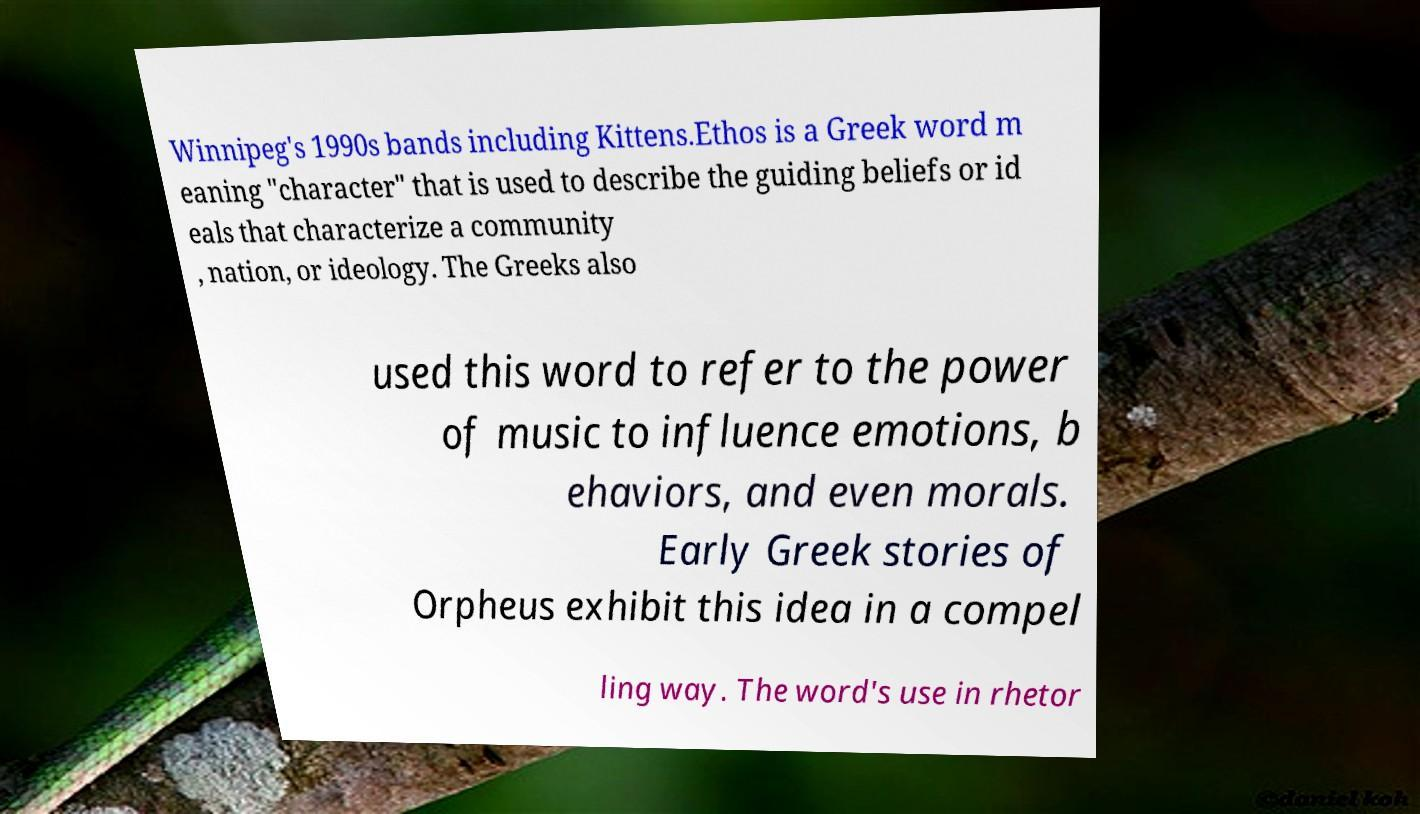For documentation purposes, I need the text within this image transcribed. Could you provide that? Winnipeg's 1990s bands including Kittens.Ethos is a Greek word m eaning "character" that is used to describe the guiding beliefs or id eals that characterize a community , nation, or ideology. The Greeks also used this word to refer to the power of music to influence emotions, b ehaviors, and even morals. Early Greek stories of Orpheus exhibit this idea in a compel ling way. The word's use in rhetor 